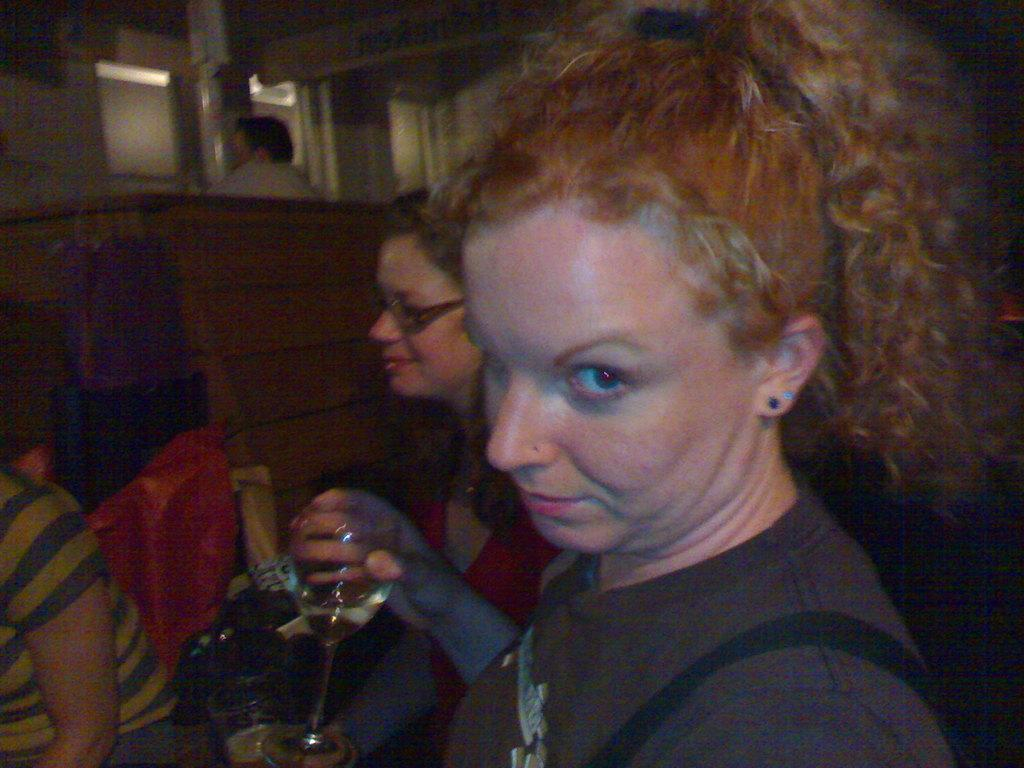Who can be seen in the image? There are people in the image. What is the woman holding in her hand? A woman is holding a glass in her hand. What can be seen in the background of the image? There are objects visible in the background of the image. What is the rate of the doll's heartbeat in the image? There is no doll present in the image, so it is not possible to determine the rate of its heartbeat. 